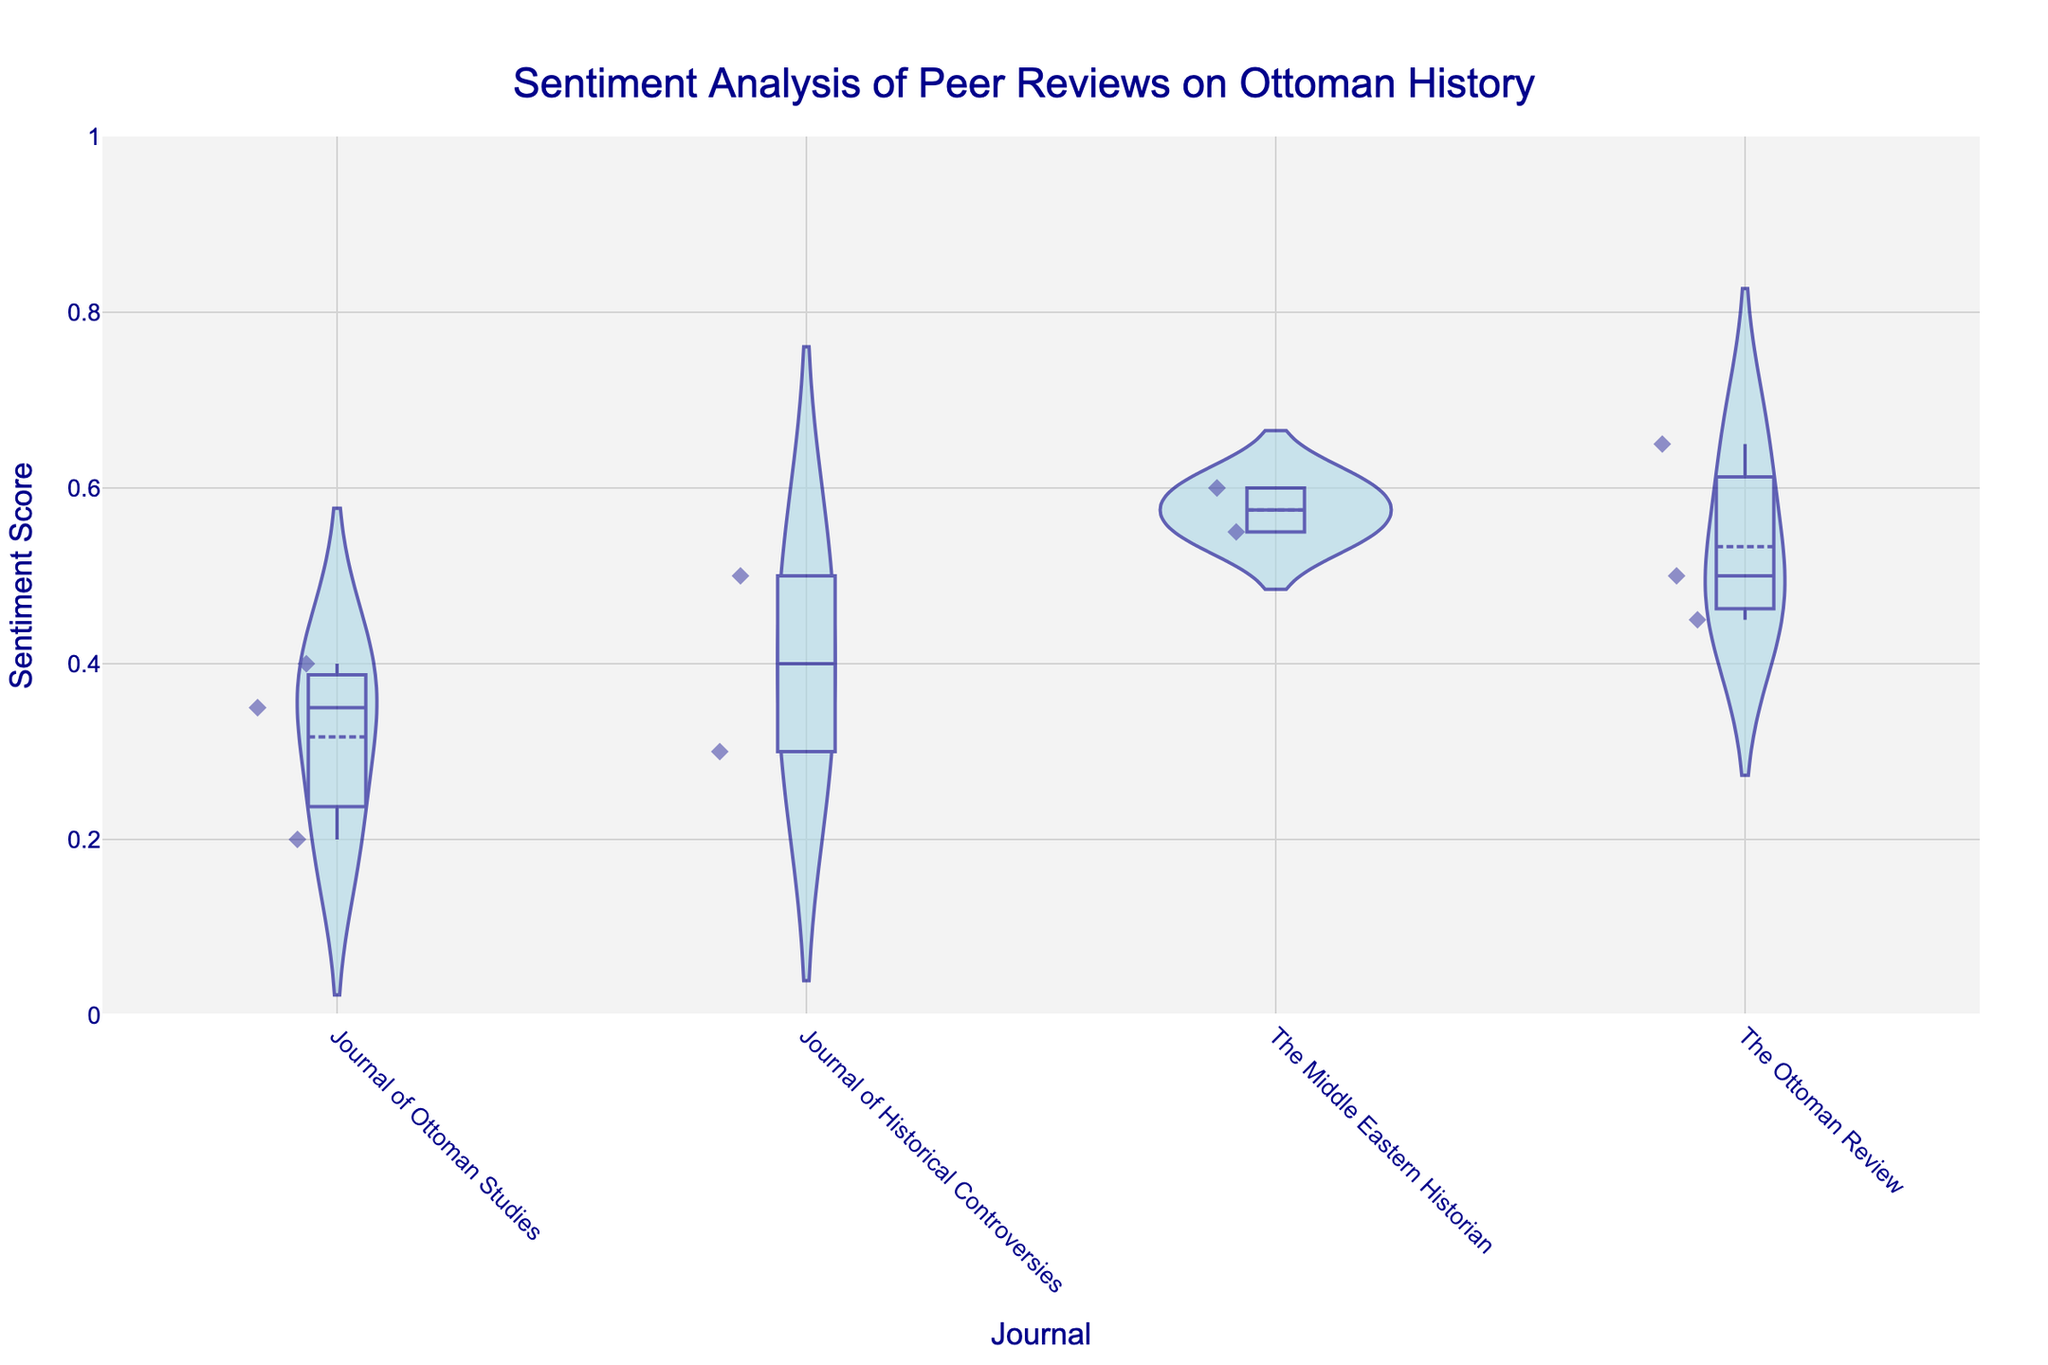What is the title of the plot? The title is displayed at the top of the figure. It reads 'Sentiment Analysis of Peer Reviews on Ottoman History'.
Answer: Sentiment Analysis of Peer Reviews on Ottoman History Which journal shows the highest median sentiment score? The median score is represented by the line inside the box within each violin plot. The highest median line appears at 'The Middle Eastern Historian'.
Answer: The Middle Eastern Historian What is the minimum sentiment score and for which journal does it apply? The minimum sentiment score is the bottom line of the box plot. It is 0.20 for the 'Journal of Ottoman Studies'.
Answer: 0.20, Journal of Ottoman Studies Which journal has the widest spread of sentiment scores? The spread is the range between the smallest and largest values in the violin plots. 'The Middle Eastern Historian' shows a wide spread from approximately 0.20 to 0.60.
Answer: The Middle Eastern Historian How does the distribution of sentiment scores in 'Journal of Historical Controversies' compare to 'The Ottoman Review'? Comparing the shapes and spreads of both violin plots reveals that 'Journal of Historical Controversies' has a distribution that ranges from around 0.30 to 0.50, while 'The Ottoman Review' ranges from approximately 0.45 to 0.65.
Answer: Journal of Historical Controversies has a narrower distribution between 0.30 and 0.50, whereas The Ottoman Review ranges from 0.45 to 0.65 What is the mean sentiment score for 'The Middle Eastern Historian'? The mean score is indicated by the white dot within the violin plot. For 'The Middle Eastern Historian', this appears around 0.575.
Answer: 0.575 Are there any outliers in the sentiment scores for 'Journal of Ottoman Studies'? Outliers are usually represented by individual points outside the main distribution range in the violin plot. The 'Journal of Ottoman Studies' does not show any significant outliers.
Answer: No Which journal has the highest sentiment score and what is it? The highest score comes from 'The Ottoman Review', visible at the top of its violin plot, with a score of approximately 0.65.
Answer: The Ottoman Review, 0.65 Which journal's sentiment scores are closest to each other? Closest scores will have the smallest spread. 'Journal of Historical Controversies' shows the smallest spread ranging from around 0.30 to 0.50.
Answer: Journal of Historical Controversies 